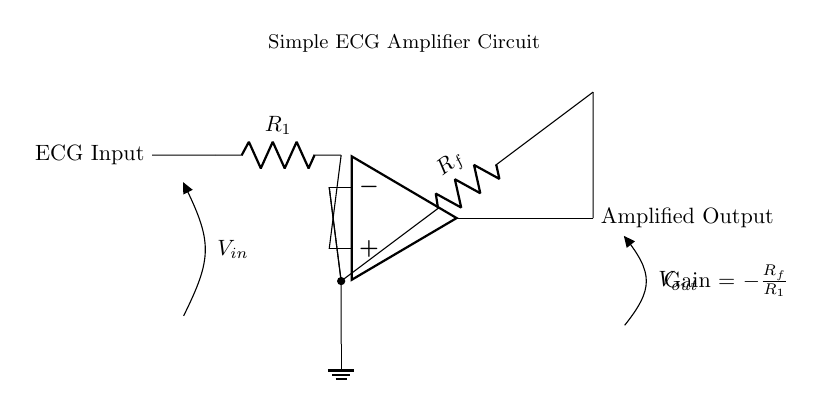What is the input of this circuit? The circuit has an ECG Input labeled on the left side, indicating where the electrical signal from the ECG device is introduced into the amplifier.
Answer: ECG Input What is the feedback resistor labeled in the circuit? In the circuit, the feedback resistor is labeled $R_f$, which is connected between the output of the operational amplifier and the inverting input (-) of the op-amp.
Answer: R_f What is the formula for gain shown in the circuit? The gain of the amplifier is indicated to be Gain = -R_f / R_1, meaning the output voltage is a scaled and inverted version of the input voltage, where R_f and R_1 are the resistances utilized in the feedback and input, respectively.
Answer: -R_f/R_1 What is the output of this circuit? The output can be found on the right side of the circuit diagram, labeled as Amplified Output, which shows where the amplified ECG signal can be accessed from the circuit.
Answer: Amplified Output Which component is used to amplify the signal? The operational amplifier, represented as the op amp in the diagram, is the main component responsible for amplifying the input signal based on the defined gain from the configuration of R_f and R_1 resistors.
Answer: Op-amp What type of signal is being amplified in this circuit? The circuit is designed to amplify ECG signals, as indicated by the label on the input, which signifies that it is processing electrical signals generated by the heart.
Answer: ECG signals 